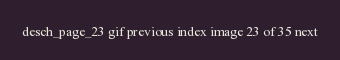<code> <loc_0><loc_0><loc_500><loc_500><_HTML_>desch_page_23 gif previous index image 23 of 35 next
</code> 